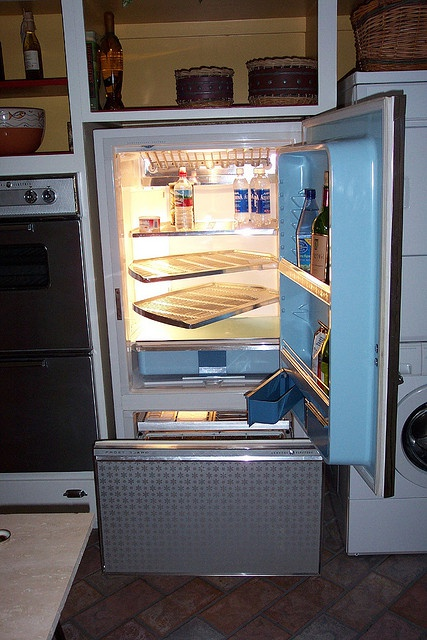Describe the objects in this image and their specific colors. I can see refrigerator in black, gray, darkgray, and ivory tones, oven in black, gray, and darkgray tones, bottle in black, maroon, and brown tones, bowl in black, maroon, and gray tones, and bottle in black, blue, navy, and gray tones in this image. 